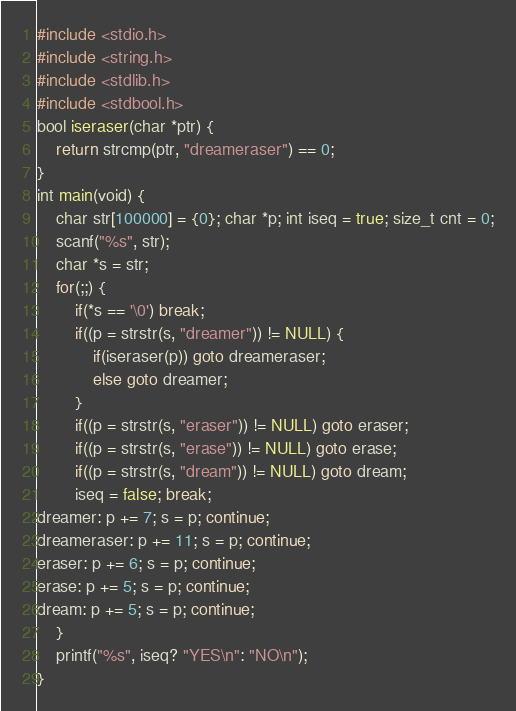<code> <loc_0><loc_0><loc_500><loc_500><_C_>#include <stdio.h>
#include <string.h>
#include <stdlib.h>
#include <stdbool.h>
bool iseraser(char *ptr) {
    return strcmp(ptr, "dreameraser") == 0;
}
int main(void) {
    char str[100000] = {0}; char *p; int iseq = true; size_t cnt = 0;
    scanf("%s", str);
    char *s = str;
    for(;;) {
        if(*s == '\0') break;
        if((p = strstr(s, "dreamer")) != NULL) {
            if(iseraser(p)) goto dreameraser;
            else goto dreamer;
        }
        if((p = strstr(s, "eraser")) != NULL) goto eraser;
        if((p = strstr(s, "erase")) != NULL) goto erase;
        if((p = strstr(s, "dream")) != NULL) goto dream;
        iseq = false; break;
dreamer: p += 7; s = p; continue;
dreameraser: p += 11; s = p; continue;
eraser: p += 6; s = p; continue;
erase: p += 5; s = p; continue;
dream: p += 5; s = p; continue;
    }
    printf("%s", iseq? "YES\n": "NO\n");
}
</code> 